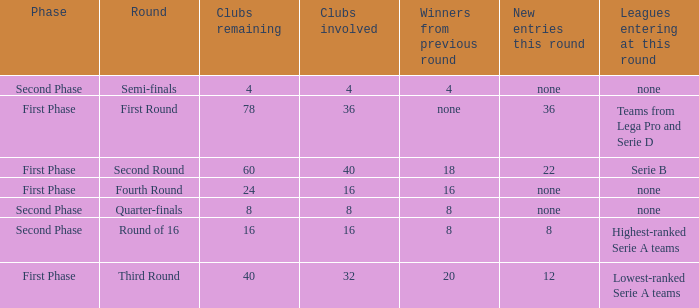Clubs involved is 8, what number would you find from winners from previous round? 8.0. 